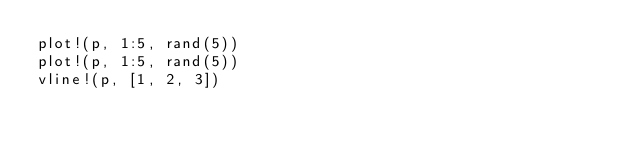<code> <loc_0><loc_0><loc_500><loc_500><_Julia_>plot!(p, 1:5, rand(5))
plot!(p, 1:5, rand(5))
vline!(p, [1, 2, 3])
</code> 